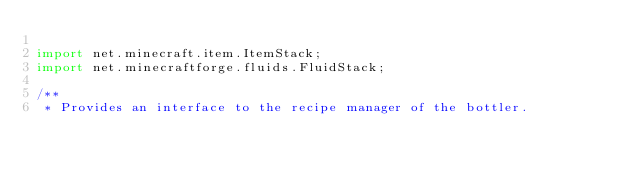Convert code to text. <code><loc_0><loc_0><loc_500><loc_500><_Java_>
import net.minecraft.item.ItemStack;
import net.minecraftforge.fluids.FluidStack;

/**
 * Provides an interface to the recipe manager of the bottler.</code> 